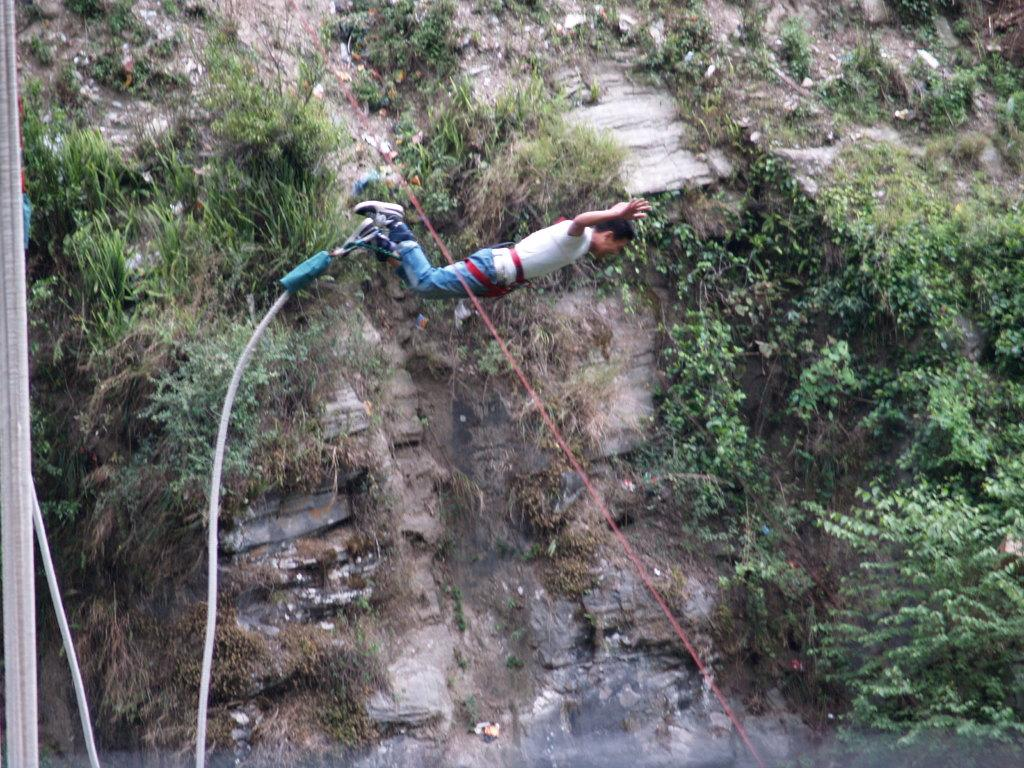Who is the main subject in the image? There is a man in the image. What activity is the man engaged in? The man is doing Bungee jumping. How is the man secured during the activity? The man is tied with a rope. Where is the rope located in the image? The rope is on the left side of the image. What type of clouds can be seen in the image? There are no clouds visible in the image, as it focuses on the man doing Bungee jumping. 